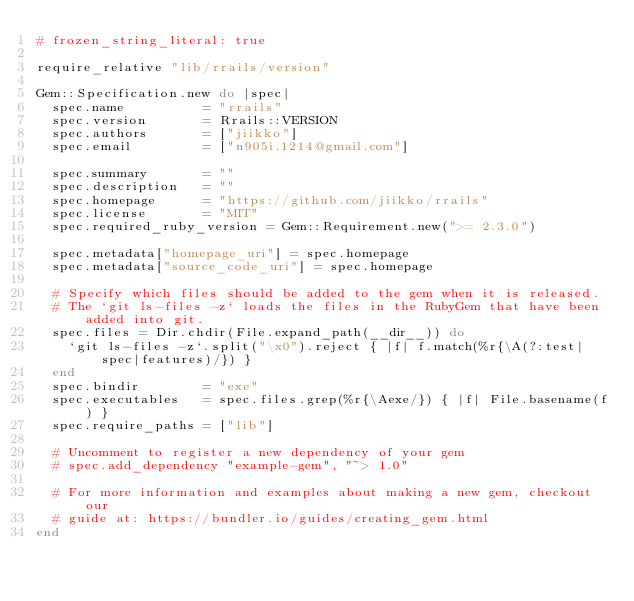<code> <loc_0><loc_0><loc_500><loc_500><_Ruby_># frozen_string_literal: true

require_relative "lib/rrails/version"

Gem::Specification.new do |spec|
  spec.name          = "rrails"
  spec.version       = Rrails::VERSION
  spec.authors       = ["jiikko"]
  spec.email         = ["n905i.1214@gmail.com"]

  spec.summary       = ""
  spec.description   = ""
  spec.homepage      = "https://github.com/jiikko/rrails"
  spec.license       = "MIT"
  spec.required_ruby_version = Gem::Requirement.new(">= 2.3.0")

  spec.metadata["homepage_uri"] = spec.homepage
  spec.metadata["source_code_uri"] = spec.homepage

  # Specify which files should be added to the gem when it is released.
  # The `git ls-files -z` loads the files in the RubyGem that have been added into git.
  spec.files = Dir.chdir(File.expand_path(__dir__)) do
    `git ls-files -z`.split("\x0").reject { |f| f.match(%r{\A(?:test|spec|features)/}) }
  end
  spec.bindir        = "exe"
  spec.executables   = spec.files.grep(%r{\Aexe/}) { |f| File.basename(f) }
  spec.require_paths = ["lib"]

  # Uncomment to register a new dependency of your gem
  # spec.add_dependency "example-gem", "~> 1.0"

  # For more information and examples about making a new gem, checkout our
  # guide at: https://bundler.io/guides/creating_gem.html
end
</code> 